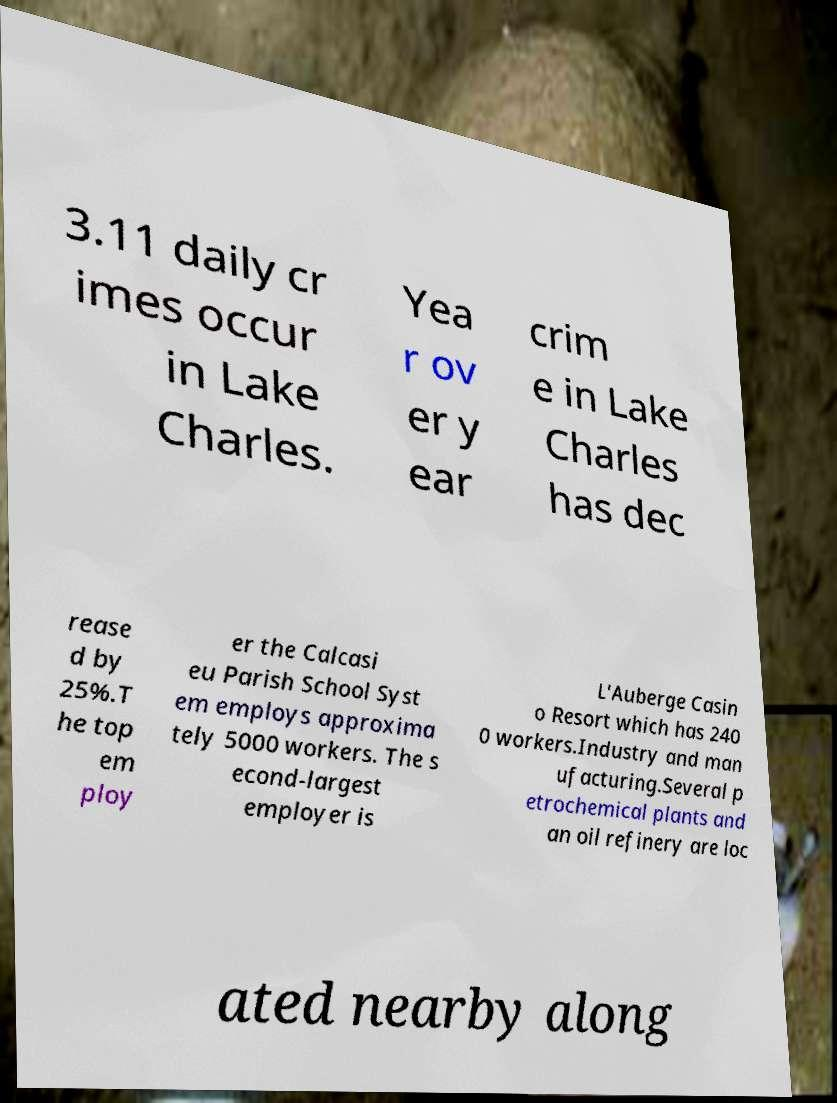Can you read and provide the text displayed in the image?This photo seems to have some interesting text. Can you extract and type it out for me? 3.11 daily cr imes occur in Lake Charles. Yea r ov er y ear crim e in Lake Charles has dec rease d by 25%.T he top em ploy er the Calcasi eu Parish School Syst em employs approxima tely 5000 workers. The s econd-largest employer is L'Auberge Casin o Resort which has 240 0 workers.Industry and man ufacturing.Several p etrochemical plants and an oil refinery are loc ated nearby along 